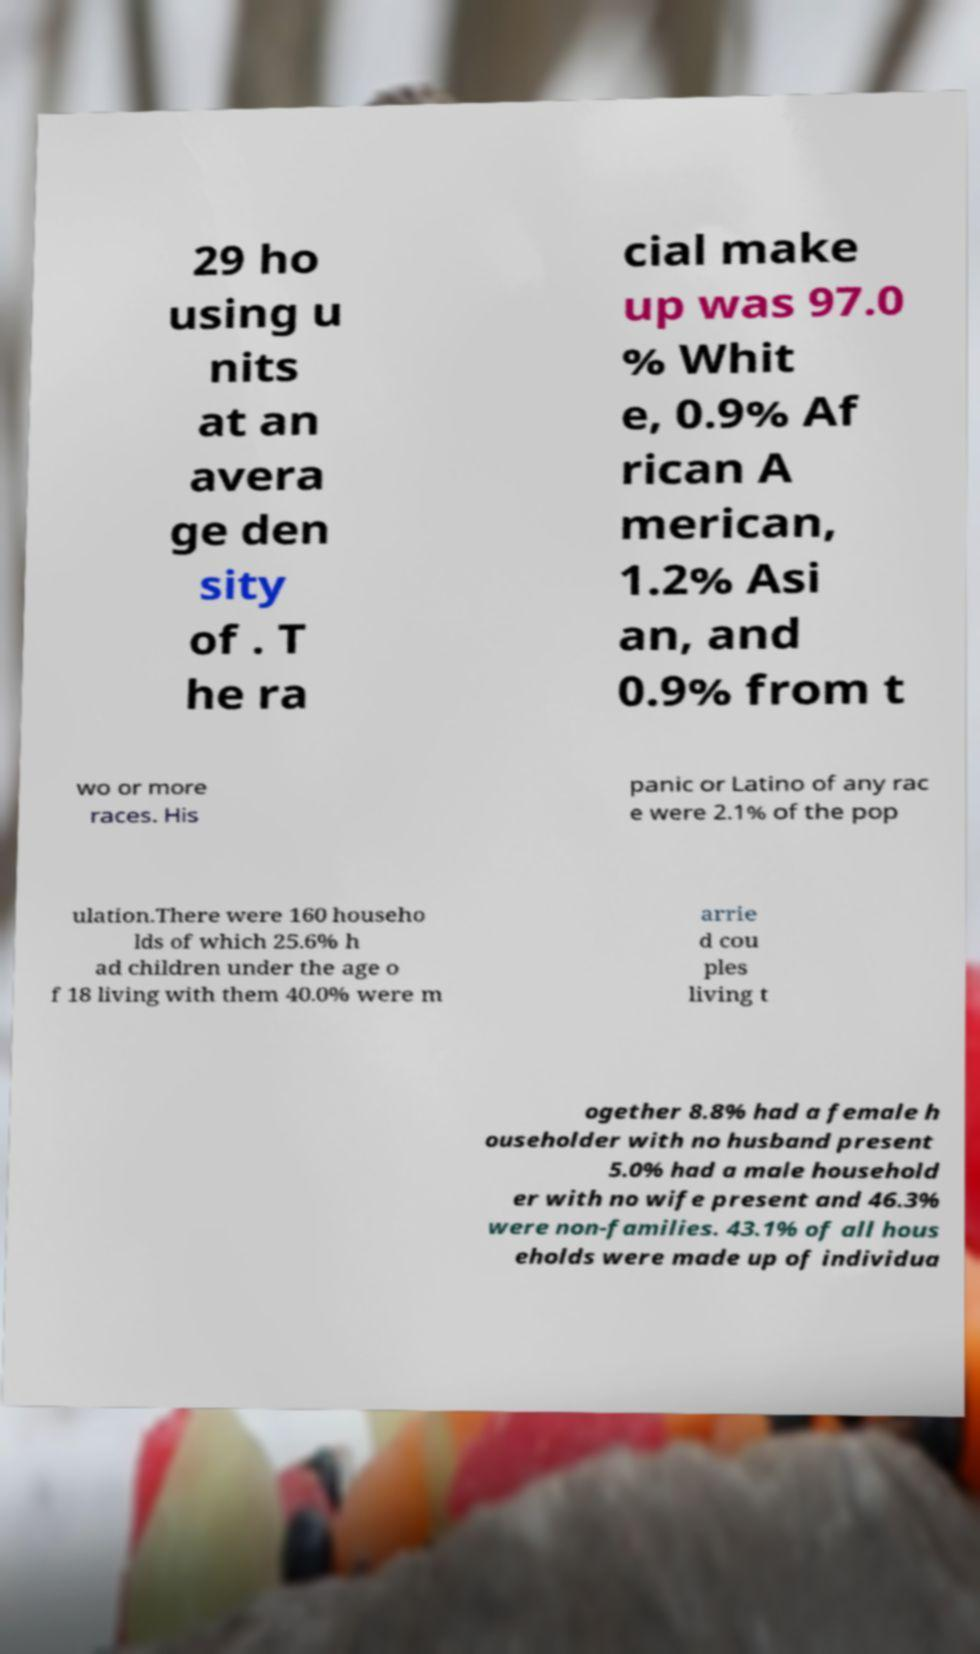Please identify and transcribe the text found in this image. 29 ho using u nits at an avera ge den sity of . T he ra cial make up was 97.0 % Whit e, 0.9% Af rican A merican, 1.2% Asi an, and 0.9% from t wo or more races. His panic or Latino of any rac e were 2.1% of the pop ulation.There were 160 househo lds of which 25.6% h ad children under the age o f 18 living with them 40.0% were m arrie d cou ples living t ogether 8.8% had a female h ouseholder with no husband present 5.0% had a male household er with no wife present and 46.3% were non-families. 43.1% of all hous eholds were made up of individua 